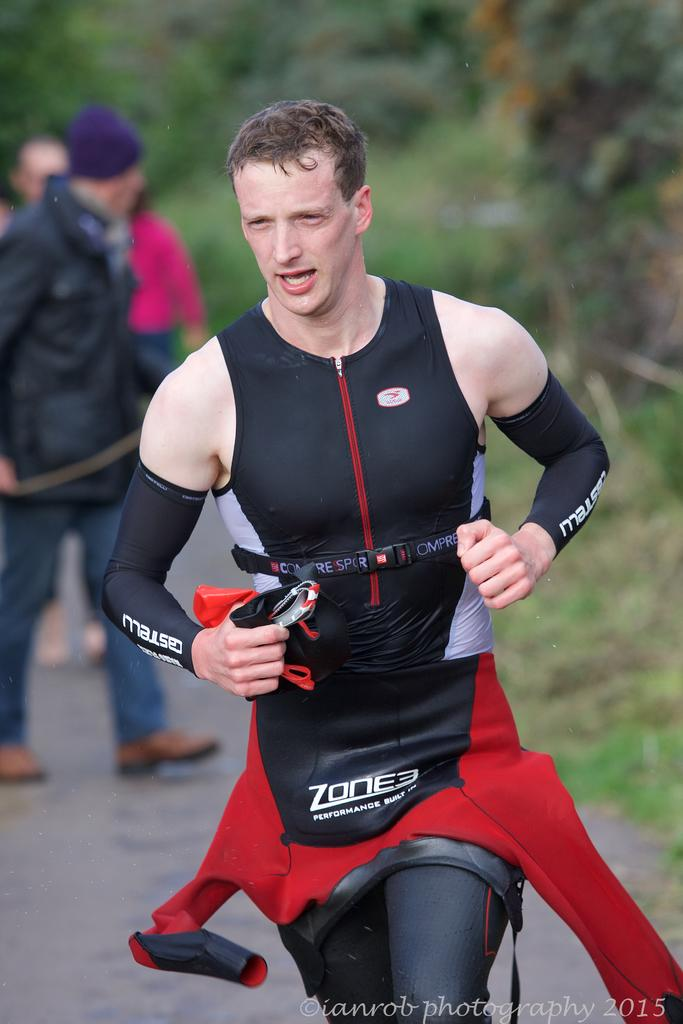Who is the main subject in the foreground of the image? There is a man in the foreground of the image. What is the man doing in the image? The man appears to be running. Are there any other people visible in the image? Yes, there are other people visible behind the man. What chess move is the man's grandmother teaching him in the image? There is no chess or grandmother present in the image; it features a man running and other people visible behind him. 